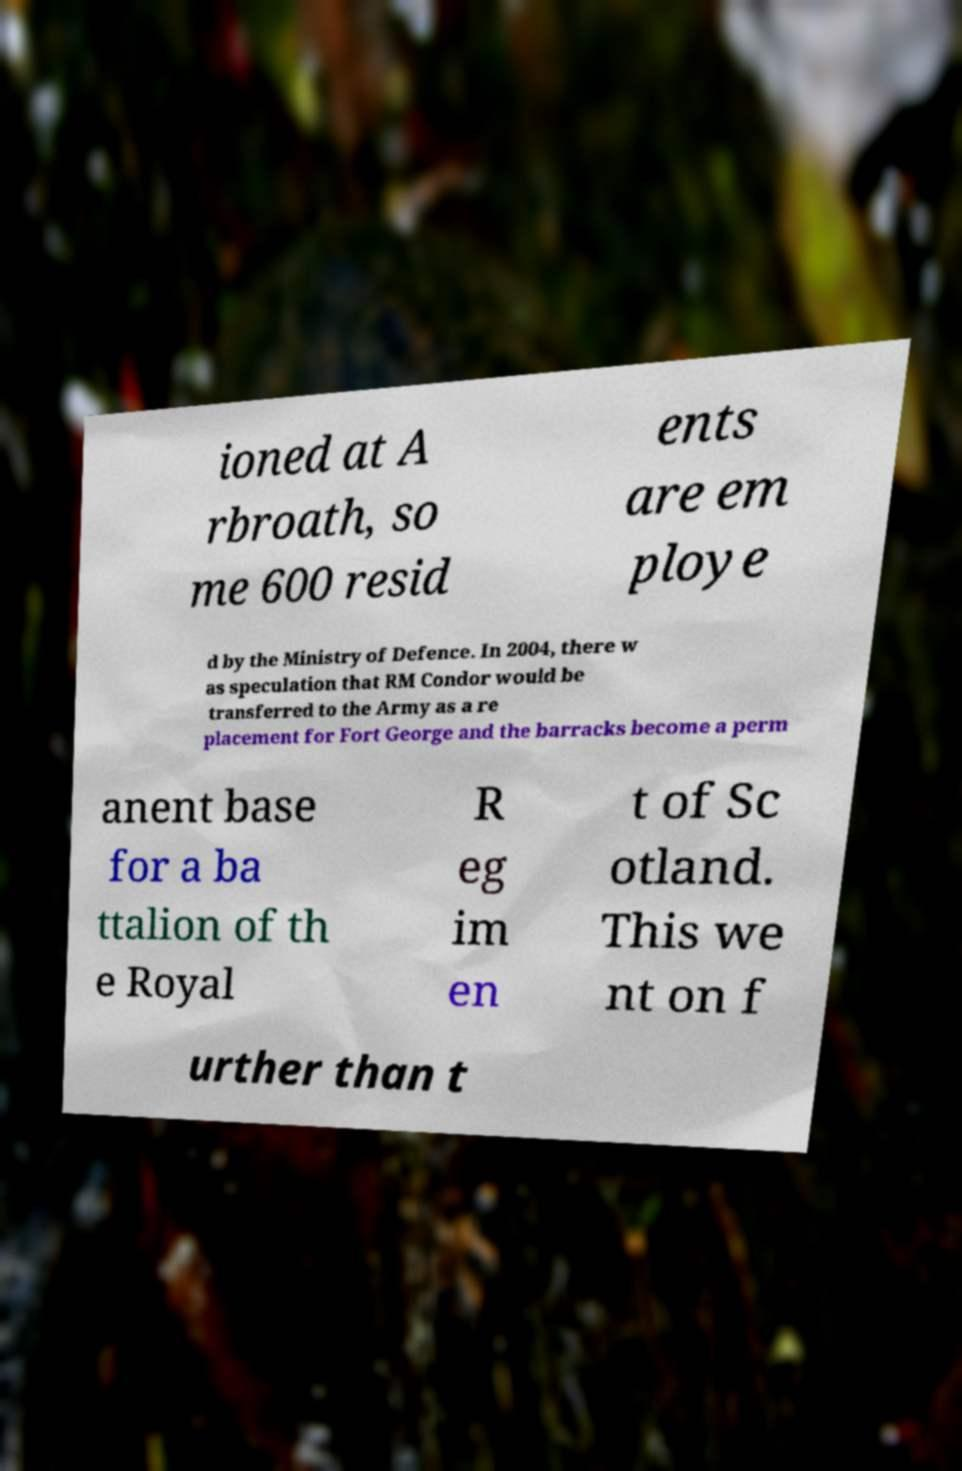Please identify and transcribe the text found in this image. ioned at A rbroath, so me 600 resid ents are em ploye d by the Ministry of Defence. In 2004, there w as speculation that RM Condor would be transferred to the Army as a re placement for Fort George and the barracks become a perm anent base for a ba ttalion of th e Royal R eg im en t of Sc otland. This we nt on f urther than t 